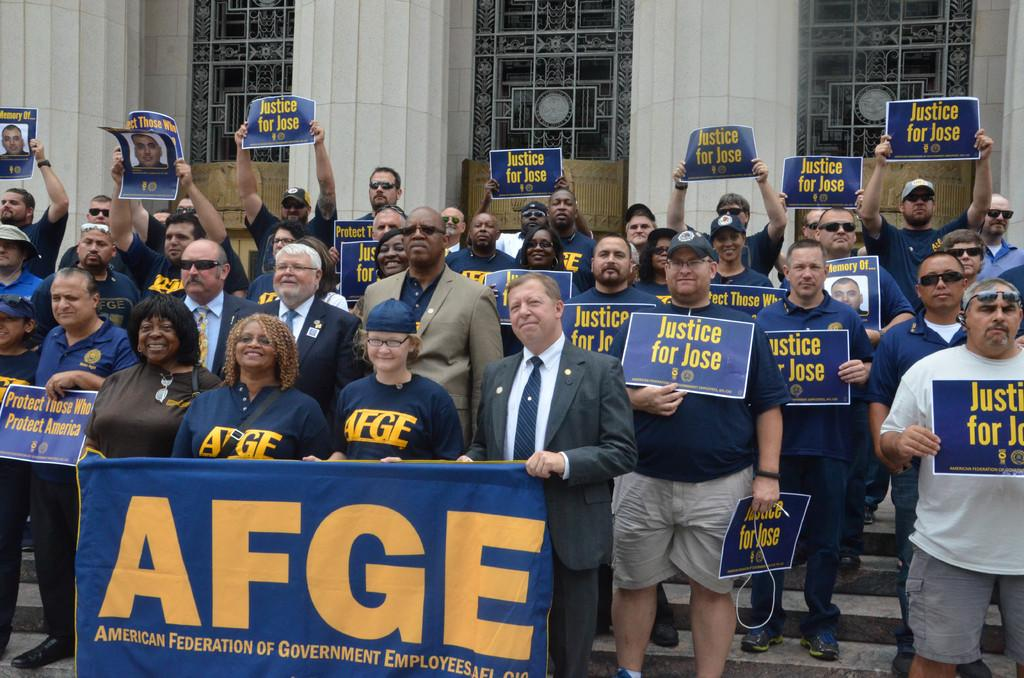What are the people in the image holding? The people in the image are holding posters and some are holding a banner. Can you describe any accessories the people are wearing? Some people are wearing caps and goggles. What can be seen in the background of the image? There is a building and steps in the background. How many geese are standing on the steps in the background? There are no geese present in the image; only people holding posters and a banner, along with some wearing caps and goggles, can be seen. Can you tell me the color of the kitty sitting on the banner? There is no kitty present in the image; only people holding posters and a banner, along with some wearing caps and goggles, can be seen. 